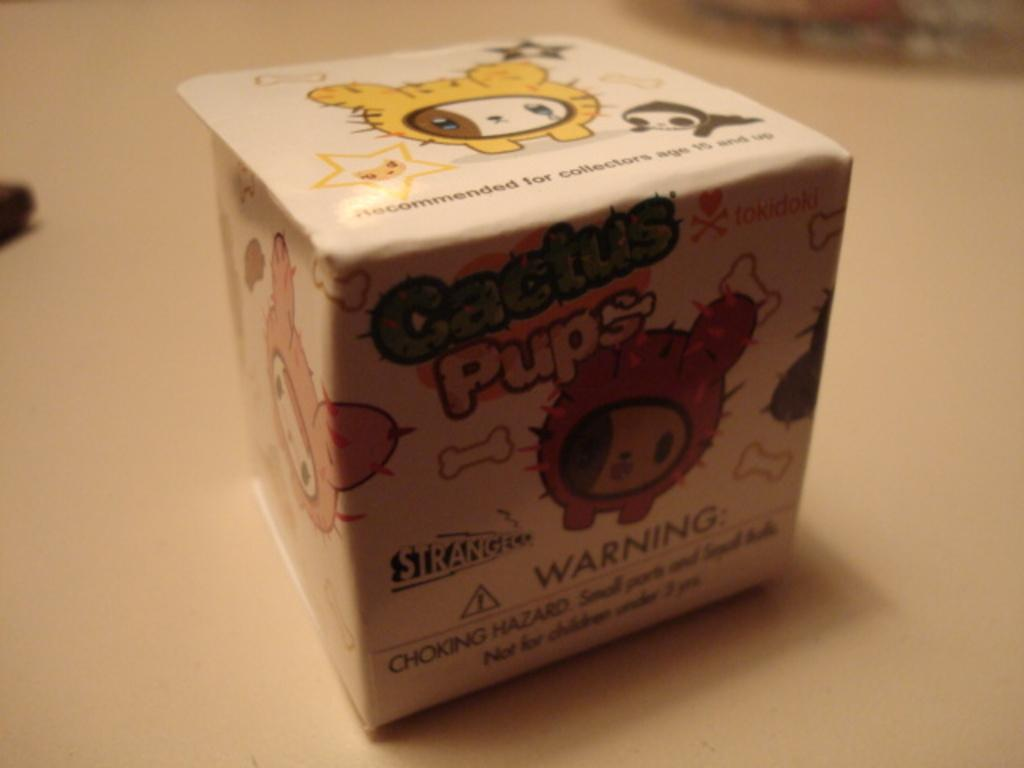<image>
Share a concise interpretation of the image provided. A box of Cactus Pups has a warning label on it. 